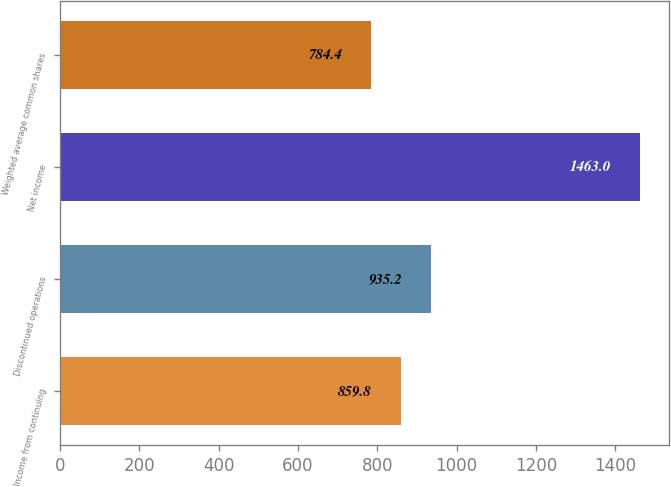<chart> <loc_0><loc_0><loc_500><loc_500><bar_chart><fcel>Income from continuing<fcel>Discontinued operations<fcel>Net income<fcel>Weighted average common shares<nl><fcel>859.8<fcel>935.2<fcel>1463<fcel>784.4<nl></chart> 